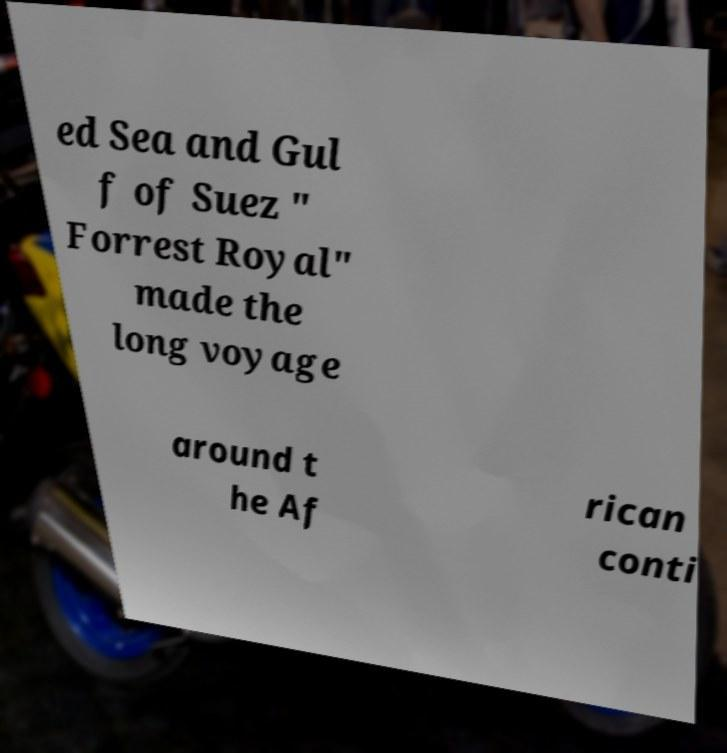Could you extract and type out the text from this image? ed Sea and Gul f of Suez " Forrest Royal" made the long voyage around t he Af rican conti 